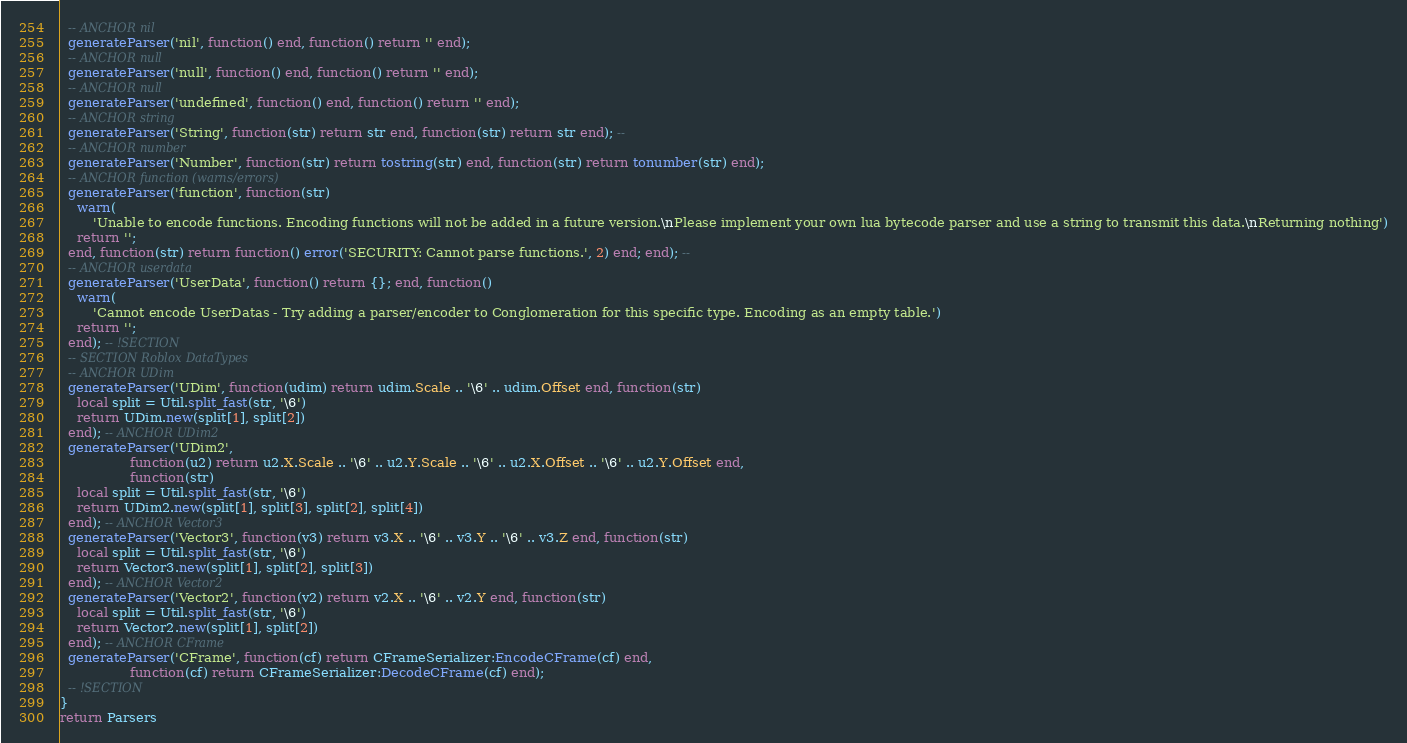<code> <loc_0><loc_0><loc_500><loc_500><_Lua_>  -- ANCHOR nil
  generateParser('nil', function() end, function() return '' end);
  -- ANCHOR null
  generateParser('null', function() end, function() return '' end);
  -- ANCHOR null
  generateParser('undefined', function() end, function() return '' end);
  -- ANCHOR string
  generateParser('String', function(str) return str end, function(str) return str end); --
  -- ANCHOR number
  generateParser('Number', function(str) return tostring(str) end, function(str) return tonumber(str) end);
  -- ANCHOR function (warns/errors)
  generateParser('function', function(str)
    warn(
        'Unable to encode functions. Encoding functions will not be added in a future version.\nPlease implement your own lua bytecode parser and use a string to transmit this data.\nReturning nothing')
    return '';
  end, function(str) return function() error('SECURITY: Cannot parse functions.', 2) end; end); --
  -- ANCHOR userdata
  generateParser('UserData', function() return {}; end, function()
    warn(
        'Cannot encode UserDatas - Try adding a parser/encoder to Conglomeration for this specific type. Encoding as an empty table.')
    return '';
  end); -- !SECTION
  -- SECTION Roblox DataTypes
  -- ANCHOR UDim
  generateParser('UDim', function(udim) return udim.Scale .. '\6' .. udim.Offset end, function(str)
    local split = Util.split_fast(str, '\6')
    return UDim.new(split[1], split[2])
  end); -- ANCHOR UDim2
  generateParser('UDim2',
                 function(u2) return u2.X.Scale .. '\6' .. u2.Y.Scale .. '\6' .. u2.X.Offset .. '\6' .. u2.Y.Offset end,
                 function(str)
    local split = Util.split_fast(str, '\6')
    return UDim2.new(split[1], split[3], split[2], split[4])
  end); -- ANCHOR Vector3
  generateParser('Vector3', function(v3) return v3.X .. '\6' .. v3.Y .. '\6' .. v3.Z end, function(str)
    local split = Util.split_fast(str, '\6')
    return Vector3.new(split[1], split[2], split[3])
  end); -- ANCHOR Vector2
  generateParser('Vector2', function(v2) return v2.X .. '\6' .. v2.Y end, function(str)
    local split = Util.split_fast(str, '\6')
    return Vector2.new(split[1], split[2])
  end); -- ANCHOR CFrame
  generateParser('CFrame', function(cf) return CFrameSerializer:EncodeCFrame(cf) end,
                 function(cf) return CFrameSerializer:DecodeCFrame(cf) end);
  -- !SECTION
}
return Parsers
</code> 